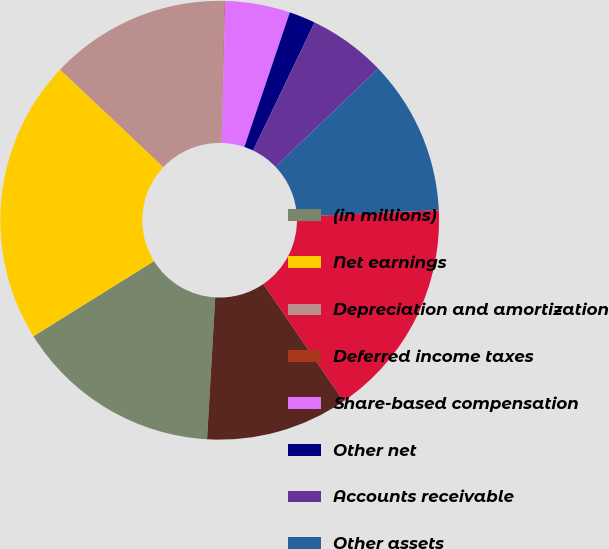Convert chart to OTSL. <chart><loc_0><loc_0><loc_500><loc_500><pie_chart><fcel>(in millions)<fcel>Net earnings<fcel>Depreciation and amortization<fcel>Deferred income taxes<fcel>Share-based compensation<fcel>Other net<fcel>Accounts receivable<fcel>Other assets<fcel>Medical costs payable<fcel>Accounts payable and other<nl><fcel>15.22%<fcel>20.91%<fcel>13.32%<fcel>0.04%<fcel>4.78%<fcel>1.94%<fcel>5.73%<fcel>11.42%<fcel>16.17%<fcel>10.47%<nl></chart> 